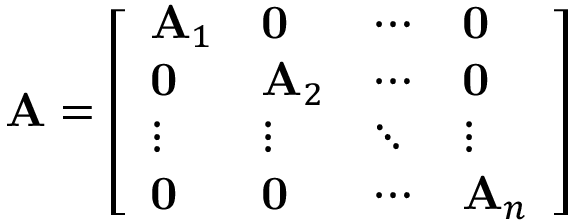Convert formula to latex. <formula><loc_0><loc_0><loc_500><loc_500>A = { \left [ \begin{array} { l l l l } { A _ { 1 } } & { 0 } & { \cdots } & { 0 } \\ { 0 } & { A _ { 2 } } & { \cdots } & { 0 } \\ { \vdots } & { \vdots } & { \ddots } & { \vdots } \\ { 0 } & { 0 } & { \cdots } & { A _ { n } } \end{array} \right ] }</formula> 